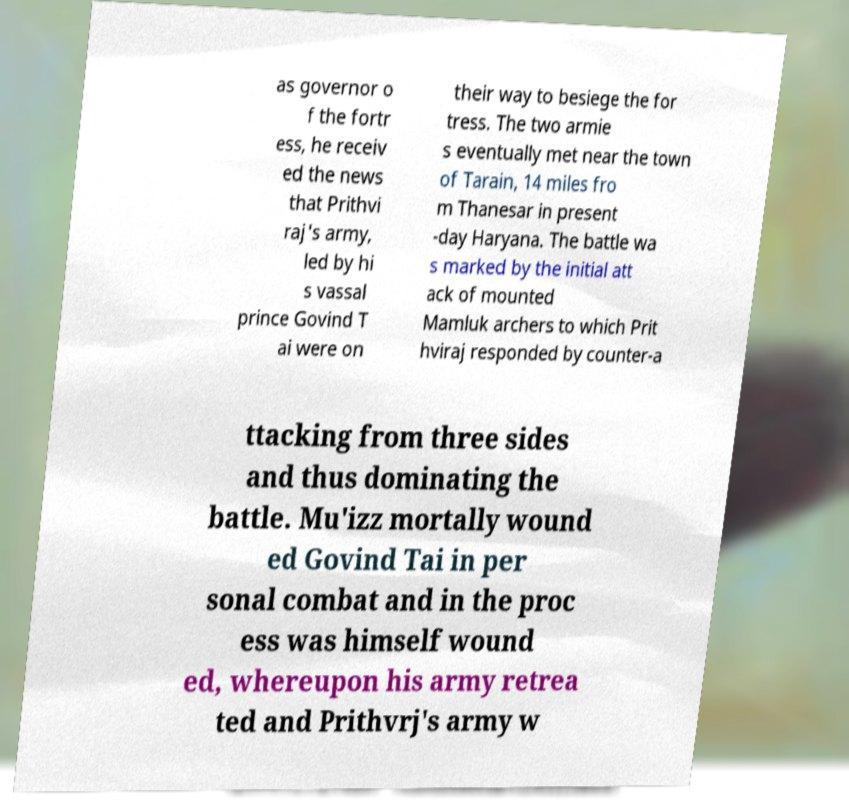What messages or text are displayed in this image? I need them in a readable, typed format. as governor o f the fortr ess, he receiv ed the news that Prithvi raj's army, led by hi s vassal prince Govind T ai were on their way to besiege the for tress. The two armie s eventually met near the town of Tarain, 14 miles fro m Thanesar in present -day Haryana. The battle wa s marked by the initial att ack of mounted Mamluk archers to which Prit hviraj responded by counter-a ttacking from three sides and thus dominating the battle. Mu'izz mortally wound ed Govind Tai in per sonal combat and in the proc ess was himself wound ed, whereupon his army retrea ted and Prithvrj's army w 